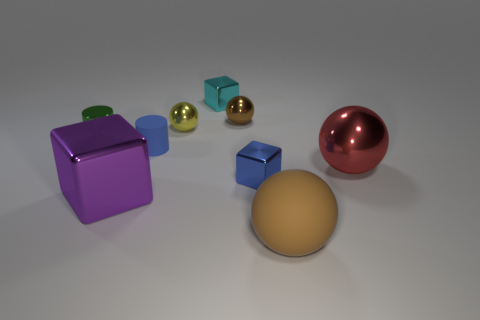Add 1 red metal spheres. How many objects exist? 10 Subtract all balls. How many objects are left? 5 Subtract all green objects. Subtract all green metallic cylinders. How many objects are left? 7 Add 8 green metallic objects. How many green metallic objects are left? 9 Add 9 small blue rubber objects. How many small blue rubber objects exist? 10 Subtract 1 blue cylinders. How many objects are left? 8 